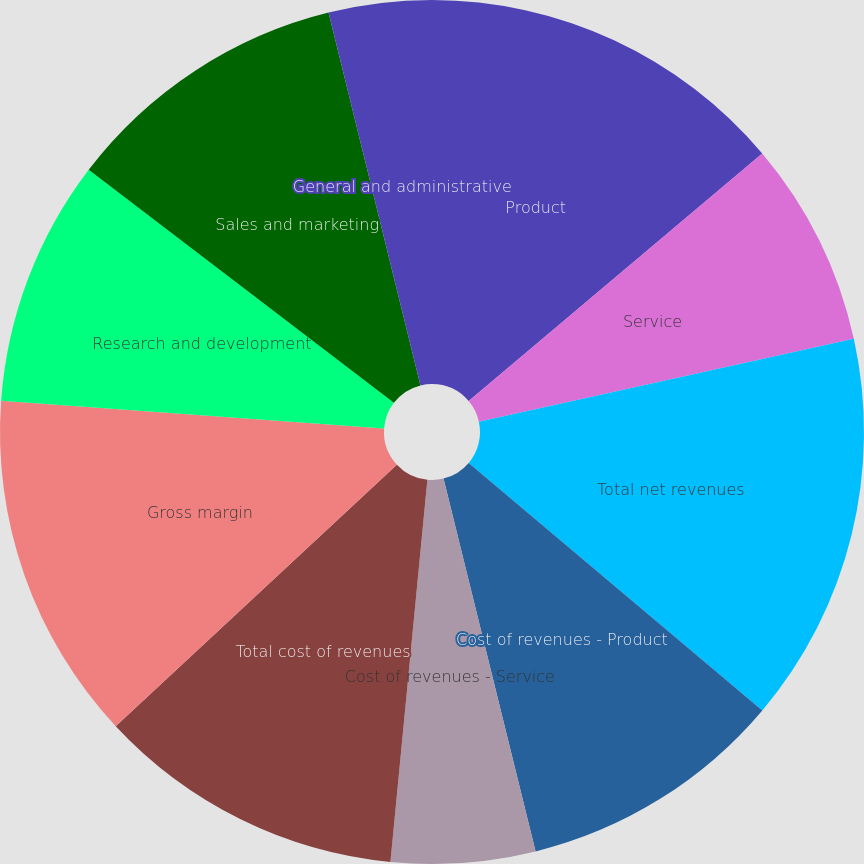Convert chart. <chart><loc_0><loc_0><loc_500><loc_500><pie_chart><fcel>Product<fcel>Service<fcel>Total net revenues<fcel>Cost of revenues - Product<fcel>Cost of revenues - Service<fcel>Total cost of revenues<fcel>Gross margin<fcel>Research and development<fcel>Sales and marketing<fcel>General and administrative<nl><fcel>13.85%<fcel>7.69%<fcel>14.61%<fcel>10.0%<fcel>5.39%<fcel>11.54%<fcel>13.08%<fcel>9.23%<fcel>10.77%<fcel>3.85%<nl></chart> 